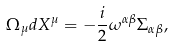Convert formula to latex. <formula><loc_0><loc_0><loc_500><loc_500>\Omega _ { \mu } d X ^ { \mu } = - \frac { i } { 2 } \omega ^ { \alpha \beta } \Sigma _ { \alpha \beta } ,</formula> 